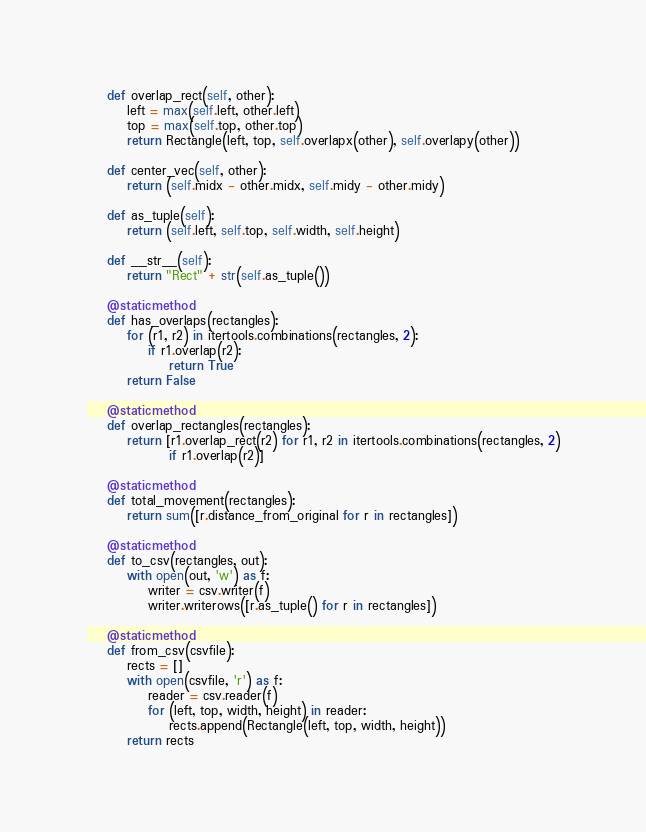<code> <loc_0><loc_0><loc_500><loc_500><_Python_>
    def overlap_rect(self, other):
        left = max(self.left, other.left)
        top = max(self.top, other.top)
        return Rectangle(left, top, self.overlapx(other), self.overlapy(other))

    def center_vec(self, other):
        return (self.midx - other.midx, self.midy - other.midy)

    def as_tuple(self):
        return (self.left, self.top, self.width, self.height)

    def __str__(self):
        return "Rect" + str(self.as_tuple())

    @staticmethod
    def has_overlaps(rectangles):
        for (r1, r2) in itertools.combinations(rectangles, 2):
            if r1.overlap(r2):
                return True
        return False

    @staticmethod
    def overlap_rectangles(rectangles):
        return [r1.overlap_rect(r2) for r1, r2 in itertools.combinations(rectangles, 2)
                if r1.overlap(r2)]

    @staticmethod
    def total_movement(rectangles):
        return sum([r.distance_from_original for r in rectangles])

    @staticmethod
    def to_csv(rectangles, out):
        with open(out, 'w') as f:
            writer = csv.writer(f)
            writer.writerows([r.as_tuple() for r in rectangles])

    @staticmethod
    def from_csv(csvfile):
        rects = []
        with open(csvfile, 'r') as f:
            reader = csv.reader(f)
            for (left, top, width, height) in reader:
                rects.append(Rectangle(left, top, width, height))
        return rects
</code> 